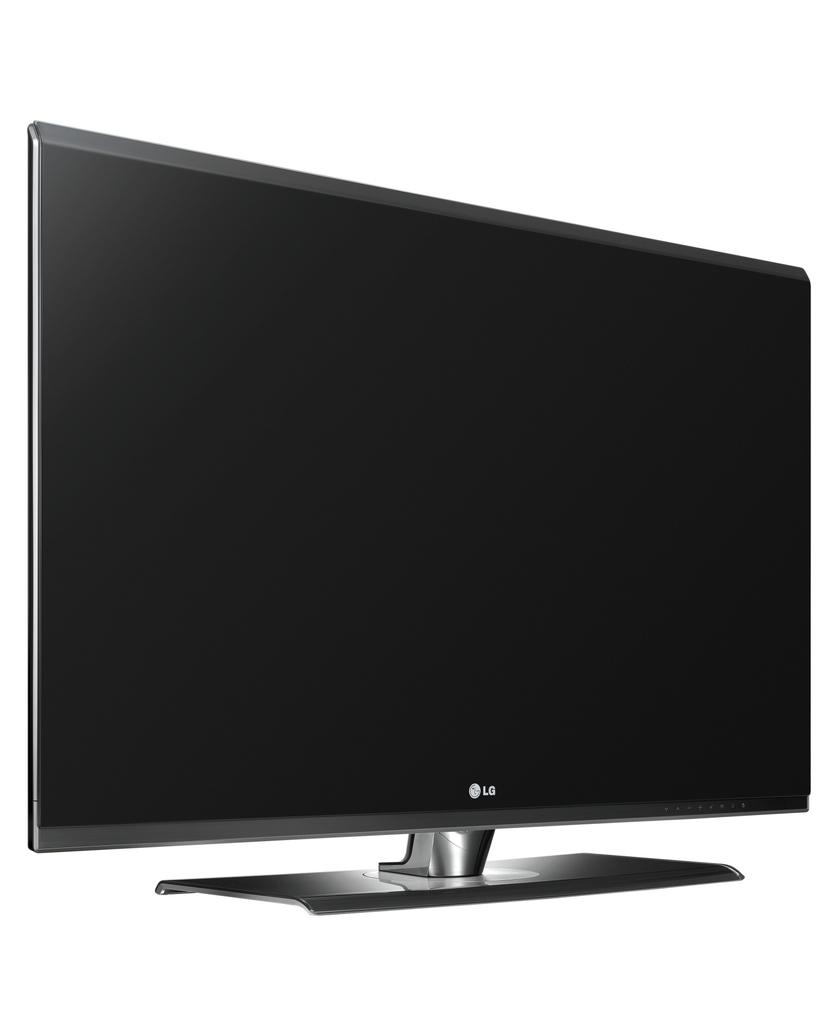<image>
Give a short and clear explanation of the subsequent image. The LG monitor is completely black and there is nothing showing on the display. 